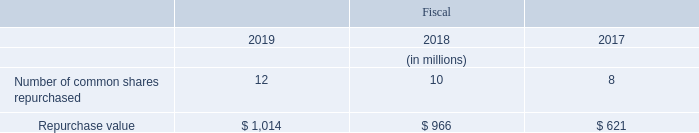Share Repurchase Program
In both fiscal 2019 and 2018, our board of directors authorized increases of $1.5 billion in our share repurchase program. Common shares repurchased under the share repurchase program were as follows:
At fiscal year end 2019, we had $1.5 billion of availability remaining under our share repurchase authorization.
What was authorized by the board of directors in 2018 and 2019? Increases of $1.5 billion in our share repurchase program. What was the availability remaining under the share repurchase authorization in 2019? $1.5 billion. Which years was the Repurchase value calculated in? 2019, 2018, 2017. Which year was the Number of common shares repurchased the largest? 12>10>8
Answer: 2019. What was the change in the Number of common shares repurchased in 2019 from 2018?
Answer scale should be: million. 12-10
Answer: 2. What was the percentage change in the Number of common shares repurchased in 2019 from 2018?
Answer scale should be: percent. (12-10)/10
Answer: 20. 